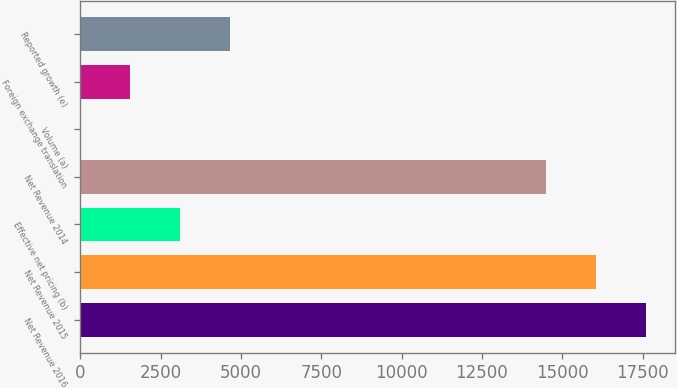<chart> <loc_0><loc_0><loc_500><loc_500><bar_chart><fcel>Net Revenue 2016<fcel>Net Revenue 2015<fcel>Effective net pricing (b)<fcel>Net Revenue 2014<fcel>Volume (a)<fcel>Foreign exchange translation<fcel>Reported growth (e)<nl><fcel>17611.6<fcel>16056.8<fcel>3110.6<fcel>14502<fcel>1<fcel>1555.8<fcel>4665.4<nl></chart> 